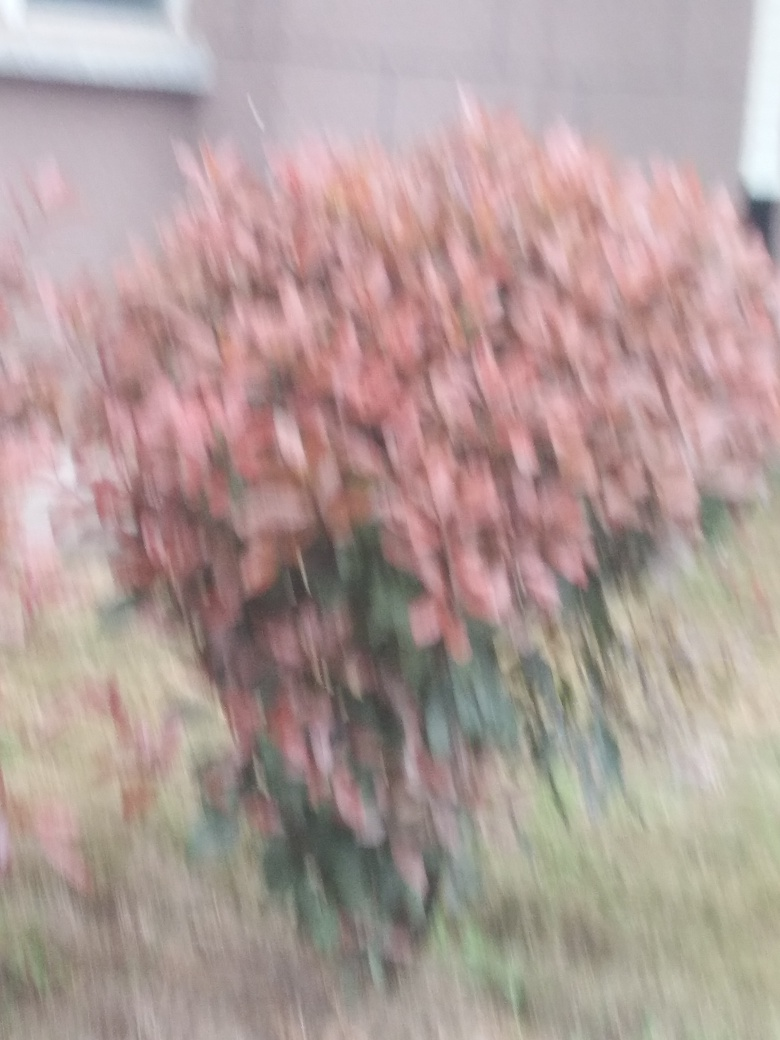What can be done to prevent this type of blurriness in future photographs? To reduce blurriness in photographs, ensure the camera is stable, possibly by using a tripod or a steady surface. Adjust the shutter speed to be faster, especially for moving subjects, and make sure the autofocus is properly set or focus manually for more precision. Additionally, good lighting can help the camera sensor capture the image more sharply. 